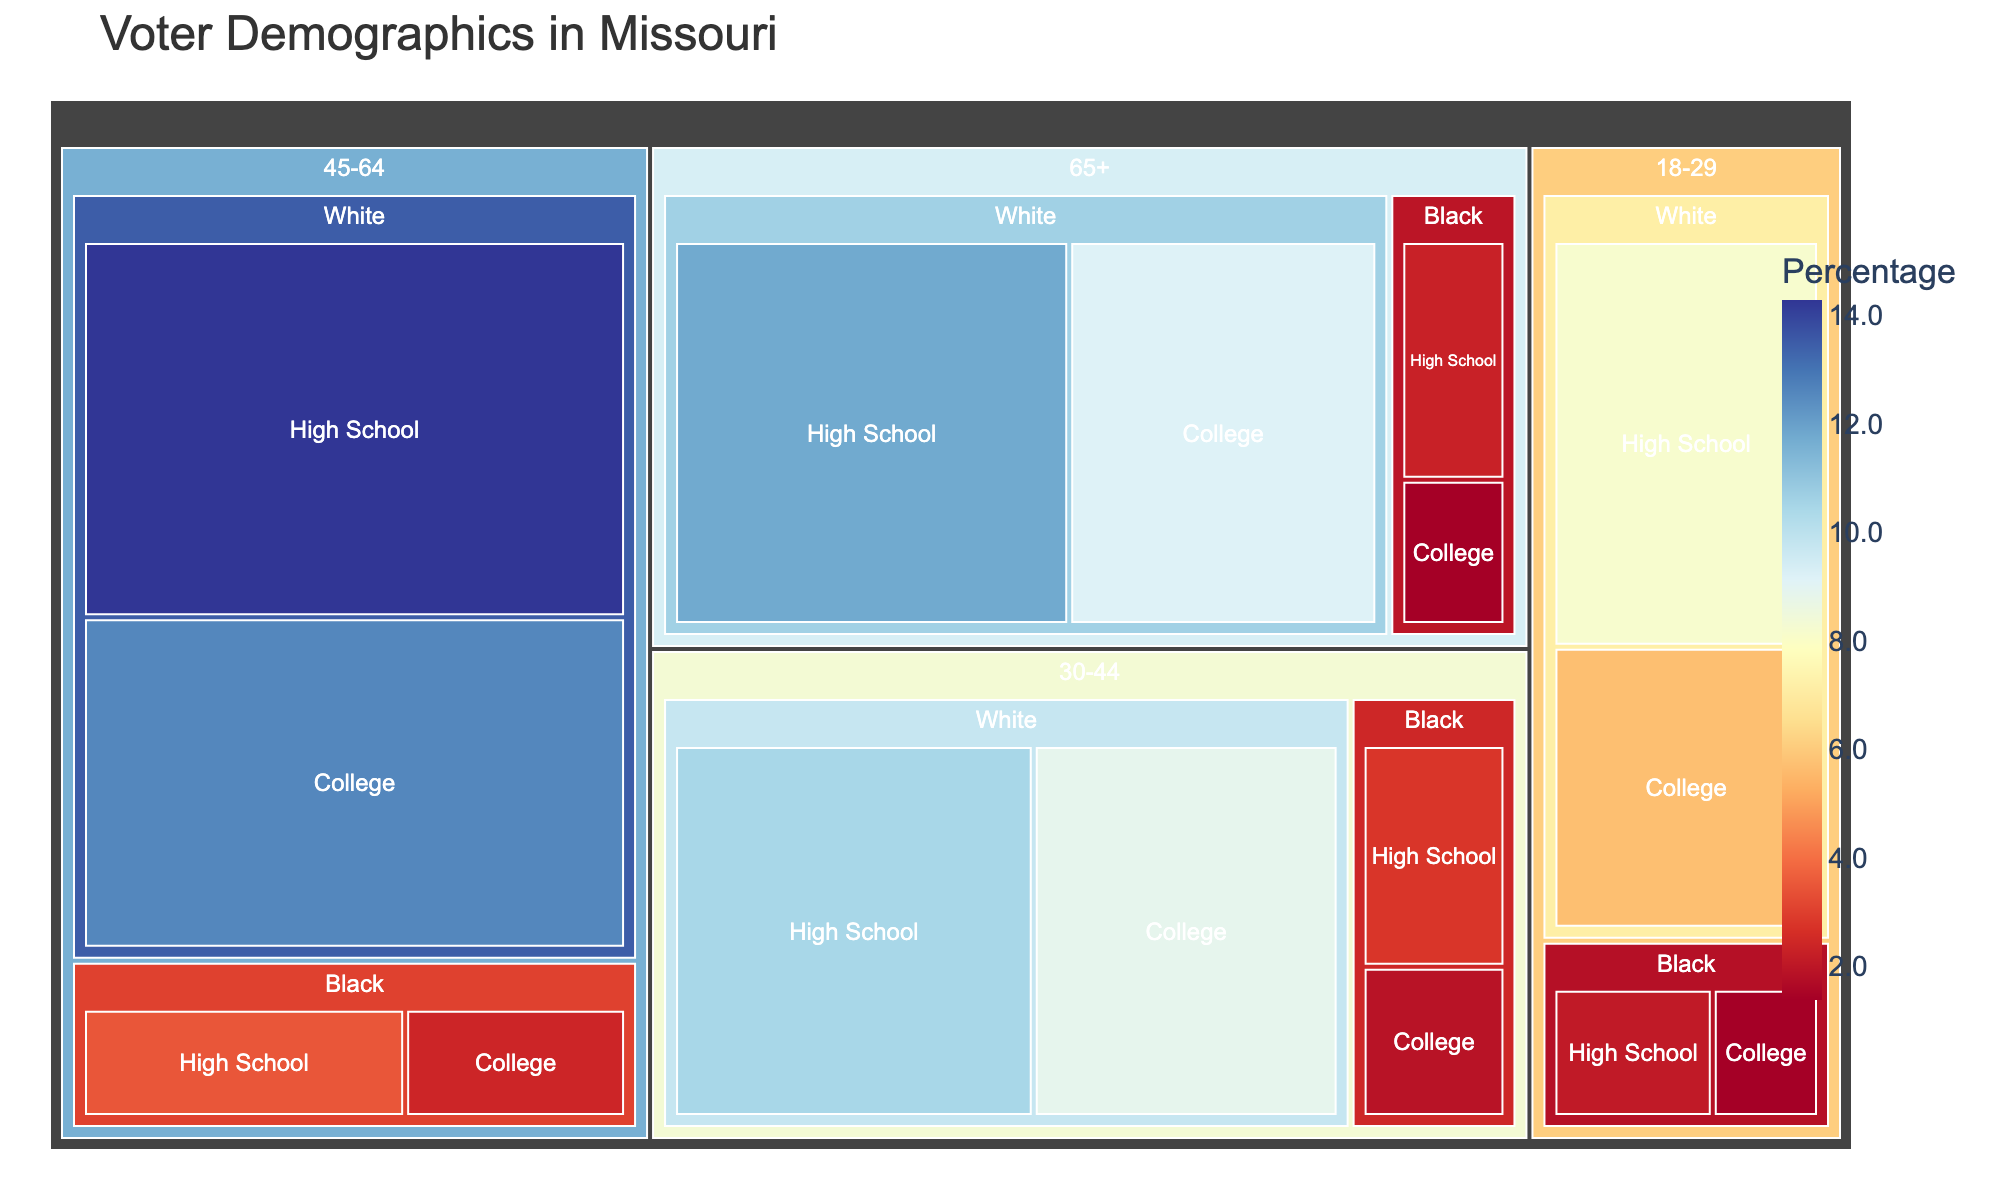Which Age group has the highest voter demographic? The figure shows each age group's proportion, color-coded by percentage. By comparing the sizes and colors of the sections, we see that the 45-64 age group has the highest percentage demographic.
Answer: 45-64 Which education level within 45-64 White demographics has the higher voter percentage? Within the 45-64 age group, look at the White demographic’s segments labeled "High School" and "College", represented respectively by the percentages 14.3 and 12.6. High School has a higher percentage.
Answer: High School What's the total percentage for the Black demographic across all age groups? Sum the percentages for the Black demographic across all age groups: 18-29: 2.1 + 1.4 = 3.5, 30-44: 2.8 + 1.9 = 4.7, 45-64: 3.5 + 2.4 = 5.9, 65+: 2.3 + 1.4 = 3.7, so the total is 3.5 + 4.7 + 5.9 + 3.7 = 17.8
Answer: 17.8 Compare voter percentages between the highest and lowest white demographics by educational level. Identify the categories with the highest and lowest percentages within the White demographic: the highest is 45-64 High School at 14.3 and the lowest is 18-29 College at 5.7. The difference is 14.3 - 5.7 = 8.6
Answer: 8.6 Find the average voter percentage for the White, High School demographic across all age groups. Sum the percentages for the White, High School demographic (8.2 + 10.5 + 14.3 + 11.8) and divide by the number of age groups (4), so (8.2 + 10.5 + 14.3 + 11.8) / 4 = 44.8 / 4 = 11.2
Answer: 11.2 Which specific voter demographic (age, race, education) has the lowest percentage? Locate the smallest labeled segment in the figure, which is the 18-29 Black College segment at 1.4%.
Answer: 18-29 Black College Compare the voter demographics of 30-44 White High School and 65+ White High School groups. Which one is larger? Examine and compare the sizes and percentages of these groups: 30-44 White High School is 10.5%, and 65+ White High School is 11.8%. The latter is larger.
Answer: 65+ White High School Is there any age group where the Black College demographic has equal or greater percentage than the White High School demographic? By comparing segments: 18-29, 1.4 < 8.2; 30-44, 1.9 < 10.5; 45-64, 2.4 < 14.3; 65+, 1.4 < 11.8. In all cases, Black College percentages are smaller.
Answer: No 